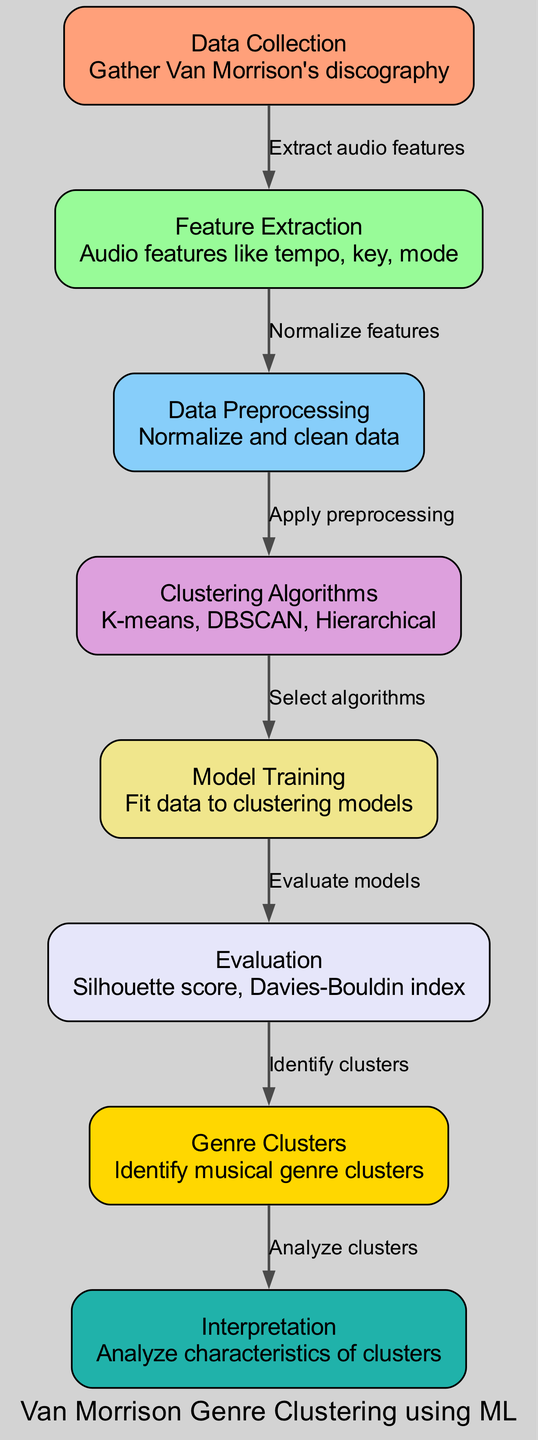What is the first step in the diagram? The first step is "Data Collection," which entails gathering Van Morrison's discography.
Answer: Data Collection How many nodes are in the diagram? There are eight nodes representing different stages of the clustering process.
Answer: Eight What is the relationship between "Feature Extraction" and "Data Preprocessing"? "Feature Extraction" leads to "Data Preprocessing," indicating that features are normalized after extraction.
Answer: Normalize features What clustering algorithms are mentioned in the diagram? The algorithms listed are K-means, DBSCAN, and Hierarchical.
Answer: K-means, DBSCAN, Hierarchical What step comes directly after "Model Training"? The step that follows "Model Training" is "Evaluation," where the models are evaluated after being trained.
Answer: Evaluation Which node comes before "Genre Clusters"? The node that comes before "Genre Clusters" is "Evaluation," indicating that clusters are identified only after evaluation is complete.
Answer: Evaluation Which node describes the analysis of characteristics of clusters? The node responsible for analyzing characteristics of clusters is "Interpretation."
Answer: Interpretation What is the purpose of the "Evaluation" node? The purpose of the "Evaluation" node is to assess the performance of models using metrics like the silhouette score and Davies-Bouldin index.
Answer: Silhouette score, Davies-Bouldin index 